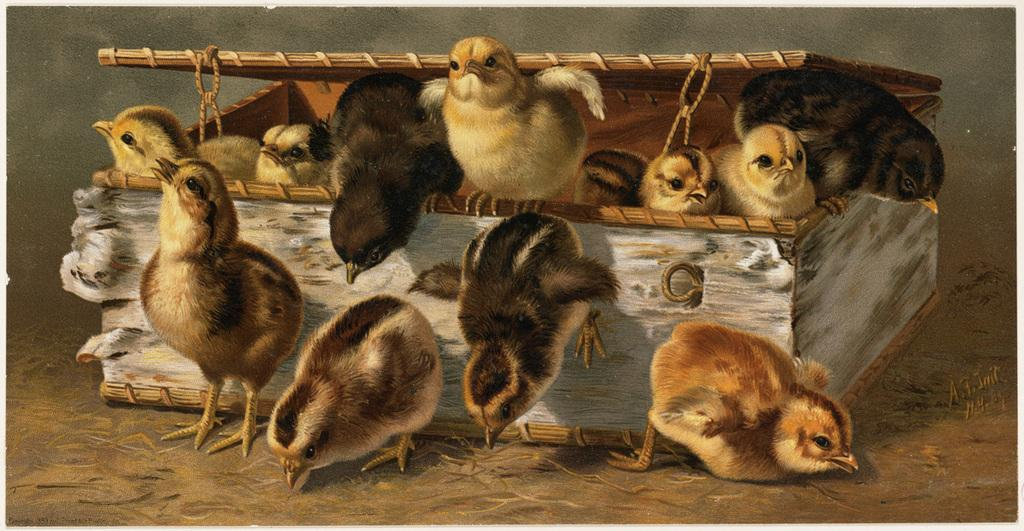What is the main subject of the image? The main subject of the image is chicks. Where are the chicks located in the image? The chicks are in the center of the image and beside a box. What type of marble is being used to draw on the chicks in the image? There is no marble present in the image, and the chicks are not being drawn on. 